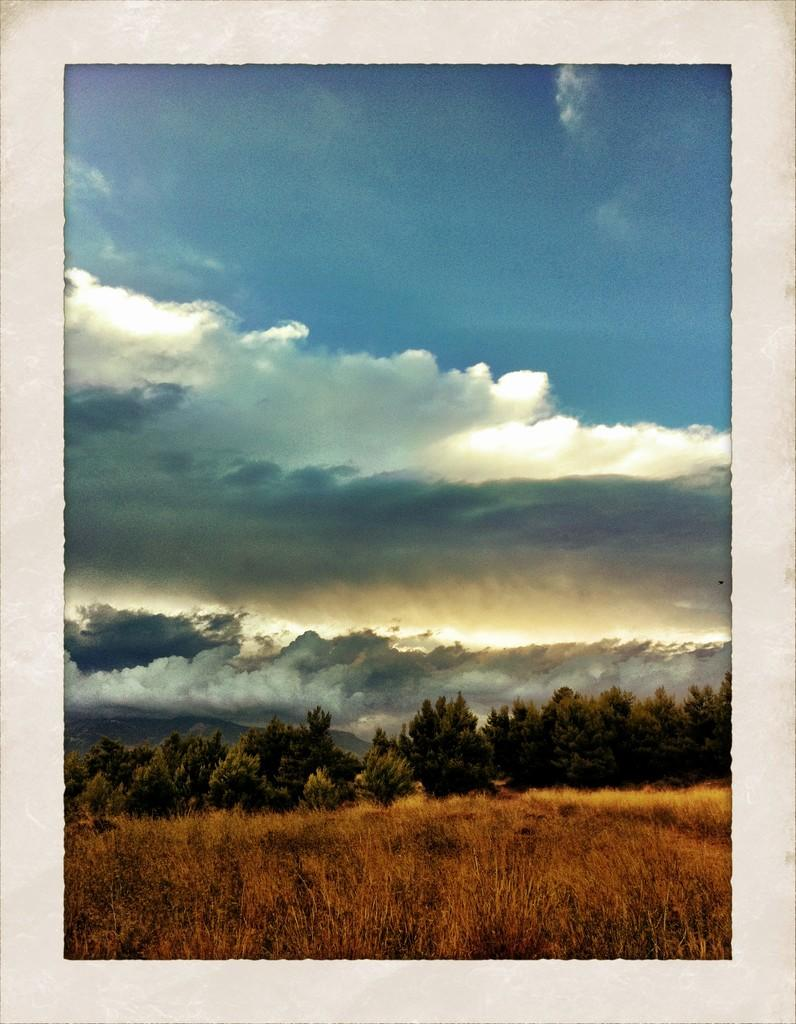What can be said about the editing of the image? The image is edited. What type of vegetation is present at the bottom of the image? There is dried grass at the bottom of the image. What other natural elements can be seen in the image? There are trees in the image. What is visible in the background of the image? The sky is visible in the background of the image. How would you describe the weather based on the sky in the image? The sky is cloudy, which suggests a partly cloudy or overcast day. What type of soap is being used to clean the trees in the image? There is no soap or cleaning activity present in the image; it features trees and a cloudy sky. What songs are being sung by the yams in the image? There are no yams or singing activity present in the image; it features trees and a cloudy sky. 